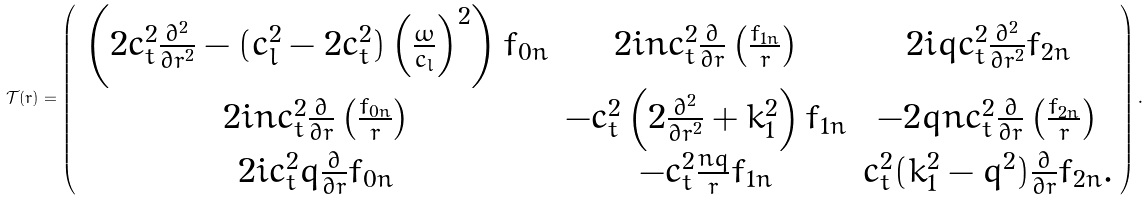<formula> <loc_0><loc_0><loc_500><loc_500>\mathcal { T } ( r ) = \left ( \begin{array} { c c c } \left ( 2 c _ { t } ^ { 2 } \frac { \partial ^ { 2 } } { \partial r ^ { 2 } } - ( c _ { l } ^ { 2 } - 2 c _ { t } ^ { 2 } ) \left ( \frac { \omega } { c _ { l } } \right ) ^ { 2 } \right ) f _ { 0 n } & 2 i n c _ { t } ^ { 2 } \frac { \partial } { \partial r } \left ( \frac { f _ { 1 n } } { r } \right ) & 2 i q c _ { t } ^ { 2 } \frac { \partial ^ { 2 } } { \partial r ^ { 2 } } f _ { 2 n } \\ 2 i n c _ { t } ^ { 2 } \frac { \partial } { \partial r } \left ( \frac { f _ { 0 n } } { r } \right ) & - c _ { t } ^ { 2 } \left ( 2 \frac { \partial ^ { 2 } } { \partial r ^ { 2 } } + k _ { 1 } ^ { 2 } \right ) f _ { 1 n } & - 2 q n c _ { t } ^ { 2 } \frac { \partial } { \partial r } \left ( \frac { f _ { 2 n } } { r } \right ) \\ 2 i c _ { t } ^ { 2 } q \frac { \partial } { \partial r } f _ { 0 n } & - c _ { t } ^ { 2 } \frac { n q } { r } f _ { 1 n } & c _ { t } ^ { 2 } ( k _ { 1 } ^ { 2 } - q ^ { 2 } ) \frac { \partial } { \partial r } f _ { 2 n } . \end{array} \right ) .</formula> 